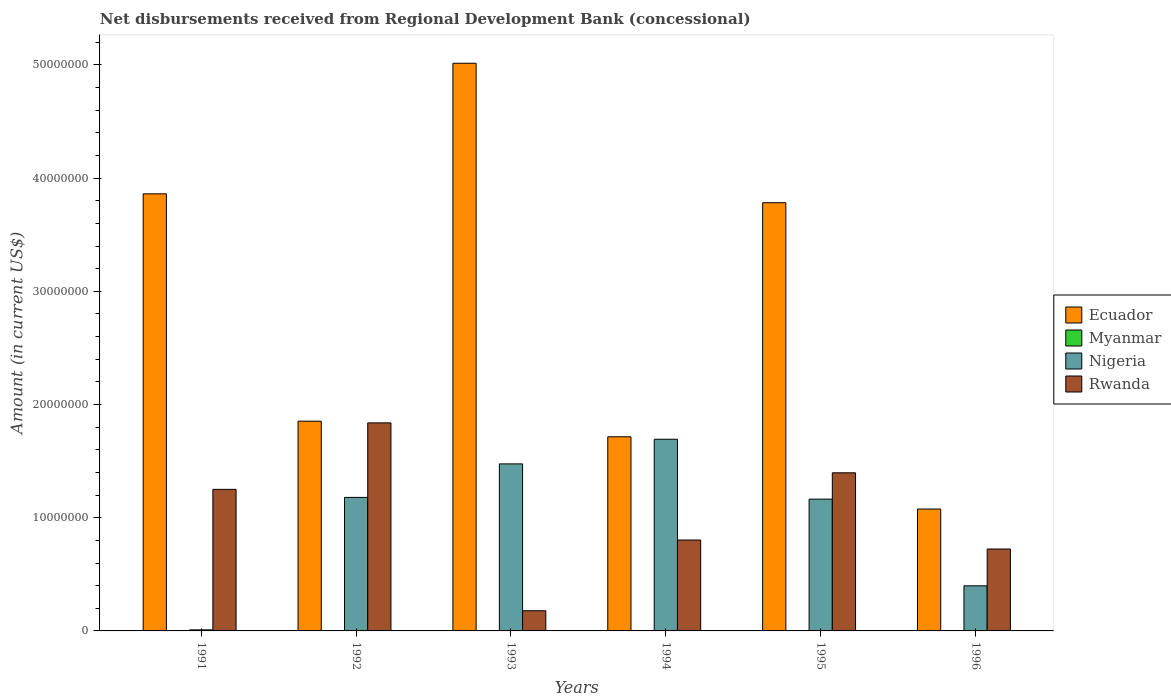How many different coloured bars are there?
Keep it short and to the point. 3. How many groups of bars are there?
Provide a short and direct response. 6. Are the number of bars per tick equal to the number of legend labels?
Your answer should be compact. No. How many bars are there on the 4th tick from the left?
Your answer should be compact. 3. How many bars are there on the 6th tick from the right?
Ensure brevity in your answer.  3. In how many cases, is the number of bars for a given year not equal to the number of legend labels?
Provide a short and direct response. 6. What is the amount of disbursements received from Regional Development Bank in Rwanda in 1993?
Ensure brevity in your answer.  1.78e+06. Across all years, what is the maximum amount of disbursements received from Regional Development Bank in Rwanda?
Your response must be concise. 1.84e+07. What is the total amount of disbursements received from Regional Development Bank in Rwanda in the graph?
Make the answer very short. 6.19e+07. What is the difference between the amount of disbursements received from Regional Development Bank in Nigeria in 1994 and that in 1996?
Offer a very short reply. 1.30e+07. What is the difference between the amount of disbursements received from Regional Development Bank in Myanmar in 1993 and the amount of disbursements received from Regional Development Bank in Rwanda in 1994?
Offer a very short reply. -8.03e+06. What is the average amount of disbursements received from Regional Development Bank in Nigeria per year?
Provide a succinct answer. 9.87e+06. In the year 1994, what is the difference between the amount of disbursements received from Regional Development Bank in Rwanda and amount of disbursements received from Regional Development Bank in Ecuador?
Make the answer very short. -9.12e+06. In how many years, is the amount of disbursements received from Regional Development Bank in Nigeria greater than 14000000 US$?
Your response must be concise. 2. What is the ratio of the amount of disbursements received from Regional Development Bank in Ecuador in 1992 to that in 1996?
Your response must be concise. 1.72. Is the amount of disbursements received from Regional Development Bank in Ecuador in 1994 less than that in 1995?
Ensure brevity in your answer.  Yes. What is the difference between the highest and the second highest amount of disbursements received from Regional Development Bank in Rwanda?
Give a very brief answer. 4.41e+06. What is the difference between the highest and the lowest amount of disbursements received from Regional Development Bank in Nigeria?
Give a very brief answer. 1.68e+07. How many bars are there?
Your answer should be very brief. 18. How many years are there in the graph?
Provide a short and direct response. 6. Are the values on the major ticks of Y-axis written in scientific E-notation?
Offer a terse response. No. Does the graph contain grids?
Offer a terse response. No. Where does the legend appear in the graph?
Your response must be concise. Center right. How many legend labels are there?
Provide a short and direct response. 4. How are the legend labels stacked?
Offer a very short reply. Vertical. What is the title of the graph?
Your answer should be very brief. Net disbursements received from Regional Development Bank (concessional). What is the label or title of the X-axis?
Keep it short and to the point. Years. What is the Amount (in current US$) in Ecuador in 1991?
Ensure brevity in your answer.  3.86e+07. What is the Amount (in current US$) of Nigeria in 1991?
Offer a terse response. 9.30e+04. What is the Amount (in current US$) in Rwanda in 1991?
Give a very brief answer. 1.25e+07. What is the Amount (in current US$) in Ecuador in 1992?
Provide a succinct answer. 1.85e+07. What is the Amount (in current US$) of Nigeria in 1992?
Offer a very short reply. 1.18e+07. What is the Amount (in current US$) in Rwanda in 1992?
Provide a succinct answer. 1.84e+07. What is the Amount (in current US$) of Ecuador in 1993?
Keep it short and to the point. 5.02e+07. What is the Amount (in current US$) of Myanmar in 1993?
Your answer should be very brief. 0. What is the Amount (in current US$) of Nigeria in 1993?
Your answer should be compact. 1.48e+07. What is the Amount (in current US$) of Rwanda in 1993?
Your response must be concise. 1.78e+06. What is the Amount (in current US$) in Ecuador in 1994?
Your answer should be very brief. 1.72e+07. What is the Amount (in current US$) in Nigeria in 1994?
Offer a terse response. 1.69e+07. What is the Amount (in current US$) of Rwanda in 1994?
Provide a short and direct response. 8.03e+06. What is the Amount (in current US$) of Ecuador in 1995?
Your answer should be very brief. 3.78e+07. What is the Amount (in current US$) of Nigeria in 1995?
Provide a short and direct response. 1.16e+07. What is the Amount (in current US$) of Rwanda in 1995?
Provide a short and direct response. 1.40e+07. What is the Amount (in current US$) in Ecuador in 1996?
Offer a very short reply. 1.08e+07. What is the Amount (in current US$) of Myanmar in 1996?
Provide a short and direct response. 0. What is the Amount (in current US$) in Nigeria in 1996?
Give a very brief answer. 3.98e+06. What is the Amount (in current US$) in Rwanda in 1996?
Your answer should be compact. 7.24e+06. Across all years, what is the maximum Amount (in current US$) of Ecuador?
Your answer should be very brief. 5.02e+07. Across all years, what is the maximum Amount (in current US$) of Nigeria?
Offer a terse response. 1.69e+07. Across all years, what is the maximum Amount (in current US$) of Rwanda?
Your answer should be compact. 1.84e+07. Across all years, what is the minimum Amount (in current US$) of Ecuador?
Provide a succinct answer. 1.08e+07. Across all years, what is the minimum Amount (in current US$) in Nigeria?
Offer a very short reply. 9.30e+04. Across all years, what is the minimum Amount (in current US$) in Rwanda?
Your answer should be very brief. 1.78e+06. What is the total Amount (in current US$) of Ecuador in the graph?
Your answer should be very brief. 1.73e+08. What is the total Amount (in current US$) in Nigeria in the graph?
Provide a short and direct response. 5.92e+07. What is the total Amount (in current US$) of Rwanda in the graph?
Offer a terse response. 6.19e+07. What is the difference between the Amount (in current US$) in Ecuador in 1991 and that in 1992?
Offer a very short reply. 2.01e+07. What is the difference between the Amount (in current US$) in Nigeria in 1991 and that in 1992?
Ensure brevity in your answer.  -1.17e+07. What is the difference between the Amount (in current US$) of Rwanda in 1991 and that in 1992?
Keep it short and to the point. -5.87e+06. What is the difference between the Amount (in current US$) of Ecuador in 1991 and that in 1993?
Provide a succinct answer. -1.15e+07. What is the difference between the Amount (in current US$) of Nigeria in 1991 and that in 1993?
Your response must be concise. -1.47e+07. What is the difference between the Amount (in current US$) in Rwanda in 1991 and that in 1993?
Make the answer very short. 1.07e+07. What is the difference between the Amount (in current US$) in Ecuador in 1991 and that in 1994?
Your answer should be compact. 2.15e+07. What is the difference between the Amount (in current US$) of Nigeria in 1991 and that in 1994?
Your response must be concise. -1.68e+07. What is the difference between the Amount (in current US$) of Rwanda in 1991 and that in 1994?
Your response must be concise. 4.48e+06. What is the difference between the Amount (in current US$) of Ecuador in 1991 and that in 1995?
Keep it short and to the point. 7.85e+05. What is the difference between the Amount (in current US$) of Nigeria in 1991 and that in 1995?
Keep it short and to the point. -1.16e+07. What is the difference between the Amount (in current US$) of Rwanda in 1991 and that in 1995?
Offer a very short reply. -1.46e+06. What is the difference between the Amount (in current US$) of Ecuador in 1991 and that in 1996?
Make the answer very short. 2.78e+07. What is the difference between the Amount (in current US$) in Nigeria in 1991 and that in 1996?
Make the answer very short. -3.89e+06. What is the difference between the Amount (in current US$) of Rwanda in 1991 and that in 1996?
Your response must be concise. 5.27e+06. What is the difference between the Amount (in current US$) of Ecuador in 1992 and that in 1993?
Provide a succinct answer. -3.16e+07. What is the difference between the Amount (in current US$) in Nigeria in 1992 and that in 1993?
Your response must be concise. -2.96e+06. What is the difference between the Amount (in current US$) of Rwanda in 1992 and that in 1993?
Keep it short and to the point. 1.66e+07. What is the difference between the Amount (in current US$) of Ecuador in 1992 and that in 1994?
Offer a terse response. 1.38e+06. What is the difference between the Amount (in current US$) of Nigeria in 1992 and that in 1994?
Provide a succinct answer. -5.14e+06. What is the difference between the Amount (in current US$) of Rwanda in 1992 and that in 1994?
Your response must be concise. 1.04e+07. What is the difference between the Amount (in current US$) of Ecuador in 1992 and that in 1995?
Offer a terse response. -1.93e+07. What is the difference between the Amount (in current US$) of Nigeria in 1992 and that in 1995?
Provide a short and direct response. 1.54e+05. What is the difference between the Amount (in current US$) in Rwanda in 1992 and that in 1995?
Your response must be concise. 4.41e+06. What is the difference between the Amount (in current US$) in Ecuador in 1992 and that in 1996?
Offer a very short reply. 7.76e+06. What is the difference between the Amount (in current US$) in Nigeria in 1992 and that in 1996?
Give a very brief answer. 7.81e+06. What is the difference between the Amount (in current US$) in Rwanda in 1992 and that in 1996?
Provide a succinct answer. 1.11e+07. What is the difference between the Amount (in current US$) in Ecuador in 1993 and that in 1994?
Provide a succinct answer. 3.30e+07. What is the difference between the Amount (in current US$) of Nigeria in 1993 and that in 1994?
Offer a very short reply. -2.18e+06. What is the difference between the Amount (in current US$) of Rwanda in 1993 and that in 1994?
Provide a succinct answer. -6.25e+06. What is the difference between the Amount (in current US$) of Ecuador in 1993 and that in 1995?
Offer a terse response. 1.23e+07. What is the difference between the Amount (in current US$) of Nigeria in 1993 and that in 1995?
Keep it short and to the point. 3.11e+06. What is the difference between the Amount (in current US$) in Rwanda in 1993 and that in 1995?
Your answer should be very brief. -1.22e+07. What is the difference between the Amount (in current US$) in Ecuador in 1993 and that in 1996?
Make the answer very short. 3.94e+07. What is the difference between the Amount (in current US$) in Nigeria in 1993 and that in 1996?
Provide a short and direct response. 1.08e+07. What is the difference between the Amount (in current US$) in Rwanda in 1993 and that in 1996?
Your answer should be compact. -5.45e+06. What is the difference between the Amount (in current US$) of Ecuador in 1994 and that in 1995?
Offer a terse response. -2.07e+07. What is the difference between the Amount (in current US$) of Nigeria in 1994 and that in 1995?
Your answer should be very brief. 5.29e+06. What is the difference between the Amount (in current US$) in Rwanda in 1994 and that in 1995?
Your response must be concise. -5.94e+06. What is the difference between the Amount (in current US$) of Ecuador in 1994 and that in 1996?
Your answer should be very brief. 6.38e+06. What is the difference between the Amount (in current US$) in Nigeria in 1994 and that in 1996?
Ensure brevity in your answer.  1.30e+07. What is the difference between the Amount (in current US$) of Rwanda in 1994 and that in 1996?
Your answer should be compact. 7.94e+05. What is the difference between the Amount (in current US$) of Ecuador in 1995 and that in 1996?
Give a very brief answer. 2.71e+07. What is the difference between the Amount (in current US$) in Nigeria in 1995 and that in 1996?
Your answer should be compact. 7.66e+06. What is the difference between the Amount (in current US$) of Rwanda in 1995 and that in 1996?
Keep it short and to the point. 6.73e+06. What is the difference between the Amount (in current US$) of Ecuador in 1991 and the Amount (in current US$) of Nigeria in 1992?
Provide a succinct answer. 2.68e+07. What is the difference between the Amount (in current US$) in Ecuador in 1991 and the Amount (in current US$) in Rwanda in 1992?
Your response must be concise. 2.02e+07. What is the difference between the Amount (in current US$) of Nigeria in 1991 and the Amount (in current US$) of Rwanda in 1992?
Your response must be concise. -1.83e+07. What is the difference between the Amount (in current US$) in Ecuador in 1991 and the Amount (in current US$) in Nigeria in 1993?
Your answer should be compact. 2.39e+07. What is the difference between the Amount (in current US$) in Ecuador in 1991 and the Amount (in current US$) in Rwanda in 1993?
Make the answer very short. 3.68e+07. What is the difference between the Amount (in current US$) in Nigeria in 1991 and the Amount (in current US$) in Rwanda in 1993?
Offer a very short reply. -1.69e+06. What is the difference between the Amount (in current US$) in Ecuador in 1991 and the Amount (in current US$) in Nigeria in 1994?
Provide a short and direct response. 2.17e+07. What is the difference between the Amount (in current US$) in Ecuador in 1991 and the Amount (in current US$) in Rwanda in 1994?
Your answer should be compact. 3.06e+07. What is the difference between the Amount (in current US$) in Nigeria in 1991 and the Amount (in current US$) in Rwanda in 1994?
Your answer should be compact. -7.94e+06. What is the difference between the Amount (in current US$) of Ecuador in 1991 and the Amount (in current US$) of Nigeria in 1995?
Offer a very short reply. 2.70e+07. What is the difference between the Amount (in current US$) of Ecuador in 1991 and the Amount (in current US$) of Rwanda in 1995?
Offer a very short reply. 2.46e+07. What is the difference between the Amount (in current US$) of Nigeria in 1991 and the Amount (in current US$) of Rwanda in 1995?
Your answer should be very brief. -1.39e+07. What is the difference between the Amount (in current US$) of Ecuador in 1991 and the Amount (in current US$) of Nigeria in 1996?
Your answer should be compact. 3.46e+07. What is the difference between the Amount (in current US$) in Ecuador in 1991 and the Amount (in current US$) in Rwanda in 1996?
Make the answer very short. 3.14e+07. What is the difference between the Amount (in current US$) in Nigeria in 1991 and the Amount (in current US$) in Rwanda in 1996?
Make the answer very short. -7.14e+06. What is the difference between the Amount (in current US$) of Ecuador in 1992 and the Amount (in current US$) of Nigeria in 1993?
Your answer should be very brief. 3.77e+06. What is the difference between the Amount (in current US$) in Ecuador in 1992 and the Amount (in current US$) in Rwanda in 1993?
Keep it short and to the point. 1.67e+07. What is the difference between the Amount (in current US$) of Nigeria in 1992 and the Amount (in current US$) of Rwanda in 1993?
Provide a succinct answer. 1.00e+07. What is the difference between the Amount (in current US$) in Ecuador in 1992 and the Amount (in current US$) in Nigeria in 1994?
Keep it short and to the point. 1.60e+06. What is the difference between the Amount (in current US$) in Ecuador in 1992 and the Amount (in current US$) in Rwanda in 1994?
Your answer should be very brief. 1.05e+07. What is the difference between the Amount (in current US$) in Nigeria in 1992 and the Amount (in current US$) in Rwanda in 1994?
Keep it short and to the point. 3.77e+06. What is the difference between the Amount (in current US$) of Ecuador in 1992 and the Amount (in current US$) of Nigeria in 1995?
Your answer should be compact. 6.89e+06. What is the difference between the Amount (in current US$) of Ecuador in 1992 and the Amount (in current US$) of Rwanda in 1995?
Provide a succinct answer. 4.56e+06. What is the difference between the Amount (in current US$) of Nigeria in 1992 and the Amount (in current US$) of Rwanda in 1995?
Offer a terse response. -2.17e+06. What is the difference between the Amount (in current US$) in Ecuador in 1992 and the Amount (in current US$) in Nigeria in 1996?
Your answer should be very brief. 1.45e+07. What is the difference between the Amount (in current US$) of Ecuador in 1992 and the Amount (in current US$) of Rwanda in 1996?
Provide a succinct answer. 1.13e+07. What is the difference between the Amount (in current US$) of Nigeria in 1992 and the Amount (in current US$) of Rwanda in 1996?
Provide a short and direct response. 4.56e+06. What is the difference between the Amount (in current US$) in Ecuador in 1993 and the Amount (in current US$) in Nigeria in 1994?
Your answer should be compact. 3.32e+07. What is the difference between the Amount (in current US$) of Ecuador in 1993 and the Amount (in current US$) of Rwanda in 1994?
Your answer should be compact. 4.21e+07. What is the difference between the Amount (in current US$) of Nigeria in 1993 and the Amount (in current US$) of Rwanda in 1994?
Offer a terse response. 6.73e+06. What is the difference between the Amount (in current US$) of Ecuador in 1993 and the Amount (in current US$) of Nigeria in 1995?
Ensure brevity in your answer.  3.85e+07. What is the difference between the Amount (in current US$) in Ecuador in 1993 and the Amount (in current US$) in Rwanda in 1995?
Your answer should be very brief. 3.62e+07. What is the difference between the Amount (in current US$) in Nigeria in 1993 and the Amount (in current US$) in Rwanda in 1995?
Offer a very short reply. 7.88e+05. What is the difference between the Amount (in current US$) of Ecuador in 1993 and the Amount (in current US$) of Nigeria in 1996?
Ensure brevity in your answer.  4.62e+07. What is the difference between the Amount (in current US$) of Ecuador in 1993 and the Amount (in current US$) of Rwanda in 1996?
Offer a very short reply. 4.29e+07. What is the difference between the Amount (in current US$) of Nigeria in 1993 and the Amount (in current US$) of Rwanda in 1996?
Offer a very short reply. 7.52e+06. What is the difference between the Amount (in current US$) of Ecuador in 1994 and the Amount (in current US$) of Nigeria in 1995?
Your answer should be compact. 5.51e+06. What is the difference between the Amount (in current US$) of Ecuador in 1994 and the Amount (in current US$) of Rwanda in 1995?
Your response must be concise. 3.18e+06. What is the difference between the Amount (in current US$) of Nigeria in 1994 and the Amount (in current US$) of Rwanda in 1995?
Provide a short and direct response. 2.97e+06. What is the difference between the Amount (in current US$) of Ecuador in 1994 and the Amount (in current US$) of Nigeria in 1996?
Your answer should be compact. 1.32e+07. What is the difference between the Amount (in current US$) in Ecuador in 1994 and the Amount (in current US$) in Rwanda in 1996?
Make the answer very short. 9.91e+06. What is the difference between the Amount (in current US$) in Nigeria in 1994 and the Amount (in current US$) in Rwanda in 1996?
Keep it short and to the point. 9.70e+06. What is the difference between the Amount (in current US$) in Ecuador in 1995 and the Amount (in current US$) in Nigeria in 1996?
Make the answer very short. 3.38e+07. What is the difference between the Amount (in current US$) of Ecuador in 1995 and the Amount (in current US$) of Rwanda in 1996?
Offer a terse response. 3.06e+07. What is the difference between the Amount (in current US$) of Nigeria in 1995 and the Amount (in current US$) of Rwanda in 1996?
Give a very brief answer. 4.41e+06. What is the average Amount (in current US$) of Ecuador per year?
Provide a short and direct response. 2.88e+07. What is the average Amount (in current US$) in Nigeria per year?
Give a very brief answer. 9.87e+06. What is the average Amount (in current US$) in Rwanda per year?
Provide a short and direct response. 1.03e+07. In the year 1991, what is the difference between the Amount (in current US$) of Ecuador and Amount (in current US$) of Nigeria?
Give a very brief answer. 3.85e+07. In the year 1991, what is the difference between the Amount (in current US$) of Ecuador and Amount (in current US$) of Rwanda?
Your response must be concise. 2.61e+07. In the year 1991, what is the difference between the Amount (in current US$) of Nigeria and Amount (in current US$) of Rwanda?
Offer a terse response. -1.24e+07. In the year 1992, what is the difference between the Amount (in current US$) of Ecuador and Amount (in current US$) of Nigeria?
Keep it short and to the point. 6.73e+06. In the year 1992, what is the difference between the Amount (in current US$) of Ecuador and Amount (in current US$) of Rwanda?
Your answer should be very brief. 1.49e+05. In the year 1992, what is the difference between the Amount (in current US$) of Nigeria and Amount (in current US$) of Rwanda?
Your response must be concise. -6.58e+06. In the year 1993, what is the difference between the Amount (in current US$) in Ecuador and Amount (in current US$) in Nigeria?
Your answer should be very brief. 3.54e+07. In the year 1993, what is the difference between the Amount (in current US$) in Ecuador and Amount (in current US$) in Rwanda?
Give a very brief answer. 4.84e+07. In the year 1993, what is the difference between the Amount (in current US$) of Nigeria and Amount (in current US$) of Rwanda?
Provide a succinct answer. 1.30e+07. In the year 1994, what is the difference between the Amount (in current US$) of Ecuador and Amount (in current US$) of Nigeria?
Ensure brevity in your answer.  2.16e+05. In the year 1994, what is the difference between the Amount (in current US$) in Ecuador and Amount (in current US$) in Rwanda?
Your response must be concise. 9.12e+06. In the year 1994, what is the difference between the Amount (in current US$) in Nigeria and Amount (in current US$) in Rwanda?
Ensure brevity in your answer.  8.90e+06. In the year 1995, what is the difference between the Amount (in current US$) of Ecuador and Amount (in current US$) of Nigeria?
Offer a very short reply. 2.62e+07. In the year 1995, what is the difference between the Amount (in current US$) of Ecuador and Amount (in current US$) of Rwanda?
Your answer should be compact. 2.39e+07. In the year 1995, what is the difference between the Amount (in current US$) of Nigeria and Amount (in current US$) of Rwanda?
Offer a terse response. -2.33e+06. In the year 1996, what is the difference between the Amount (in current US$) in Ecuador and Amount (in current US$) in Nigeria?
Your answer should be compact. 6.78e+06. In the year 1996, what is the difference between the Amount (in current US$) of Ecuador and Amount (in current US$) of Rwanda?
Provide a succinct answer. 3.53e+06. In the year 1996, what is the difference between the Amount (in current US$) of Nigeria and Amount (in current US$) of Rwanda?
Keep it short and to the point. -3.25e+06. What is the ratio of the Amount (in current US$) of Ecuador in 1991 to that in 1992?
Offer a very short reply. 2.08. What is the ratio of the Amount (in current US$) of Nigeria in 1991 to that in 1992?
Your answer should be compact. 0.01. What is the ratio of the Amount (in current US$) in Rwanda in 1991 to that in 1992?
Provide a succinct answer. 0.68. What is the ratio of the Amount (in current US$) of Ecuador in 1991 to that in 1993?
Your answer should be very brief. 0.77. What is the ratio of the Amount (in current US$) in Nigeria in 1991 to that in 1993?
Provide a succinct answer. 0.01. What is the ratio of the Amount (in current US$) of Rwanda in 1991 to that in 1993?
Offer a very short reply. 7.01. What is the ratio of the Amount (in current US$) in Ecuador in 1991 to that in 1994?
Offer a very short reply. 2.25. What is the ratio of the Amount (in current US$) of Nigeria in 1991 to that in 1994?
Your answer should be compact. 0.01. What is the ratio of the Amount (in current US$) in Rwanda in 1991 to that in 1994?
Your response must be concise. 1.56. What is the ratio of the Amount (in current US$) in Ecuador in 1991 to that in 1995?
Keep it short and to the point. 1.02. What is the ratio of the Amount (in current US$) of Nigeria in 1991 to that in 1995?
Provide a succinct answer. 0.01. What is the ratio of the Amount (in current US$) in Rwanda in 1991 to that in 1995?
Provide a succinct answer. 0.9. What is the ratio of the Amount (in current US$) of Ecuador in 1991 to that in 1996?
Keep it short and to the point. 3.59. What is the ratio of the Amount (in current US$) of Nigeria in 1991 to that in 1996?
Give a very brief answer. 0.02. What is the ratio of the Amount (in current US$) of Rwanda in 1991 to that in 1996?
Provide a short and direct response. 1.73. What is the ratio of the Amount (in current US$) of Ecuador in 1992 to that in 1993?
Keep it short and to the point. 0.37. What is the ratio of the Amount (in current US$) of Nigeria in 1992 to that in 1993?
Your response must be concise. 0.8. What is the ratio of the Amount (in current US$) in Rwanda in 1992 to that in 1993?
Offer a terse response. 10.31. What is the ratio of the Amount (in current US$) of Ecuador in 1992 to that in 1994?
Provide a short and direct response. 1.08. What is the ratio of the Amount (in current US$) in Nigeria in 1992 to that in 1994?
Provide a succinct answer. 0.7. What is the ratio of the Amount (in current US$) of Rwanda in 1992 to that in 1994?
Your response must be concise. 2.29. What is the ratio of the Amount (in current US$) in Ecuador in 1992 to that in 1995?
Your response must be concise. 0.49. What is the ratio of the Amount (in current US$) in Nigeria in 1992 to that in 1995?
Keep it short and to the point. 1.01. What is the ratio of the Amount (in current US$) of Rwanda in 1992 to that in 1995?
Make the answer very short. 1.32. What is the ratio of the Amount (in current US$) of Ecuador in 1992 to that in 1996?
Your answer should be very brief. 1.72. What is the ratio of the Amount (in current US$) in Nigeria in 1992 to that in 1996?
Ensure brevity in your answer.  2.96. What is the ratio of the Amount (in current US$) in Rwanda in 1992 to that in 1996?
Your response must be concise. 2.54. What is the ratio of the Amount (in current US$) of Ecuador in 1993 to that in 1994?
Ensure brevity in your answer.  2.92. What is the ratio of the Amount (in current US$) of Nigeria in 1993 to that in 1994?
Provide a short and direct response. 0.87. What is the ratio of the Amount (in current US$) of Rwanda in 1993 to that in 1994?
Make the answer very short. 0.22. What is the ratio of the Amount (in current US$) of Ecuador in 1993 to that in 1995?
Your response must be concise. 1.33. What is the ratio of the Amount (in current US$) in Nigeria in 1993 to that in 1995?
Keep it short and to the point. 1.27. What is the ratio of the Amount (in current US$) in Rwanda in 1993 to that in 1995?
Keep it short and to the point. 0.13. What is the ratio of the Amount (in current US$) in Ecuador in 1993 to that in 1996?
Your answer should be compact. 4.66. What is the ratio of the Amount (in current US$) in Nigeria in 1993 to that in 1996?
Keep it short and to the point. 3.7. What is the ratio of the Amount (in current US$) of Rwanda in 1993 to that in 1996?
Give a very brief answer. 0.25. What is the ratio of the Amount (in current US$) of Ecuador in 1994 to that in 1995?
Provide a succinct answer. 0.45. What is the ratio of the Amount (in current US$) of Nigeria in 1994 to that in 1995?
Your response must be concise. 1.45. What is the ratio of the Amount (in current US$) of Rwanda in 1994 to that in 1995?
Offer a terse response. 0.57. What is the ratio of the Amount (in current US$) in Ecuador in 1994 to that in 1996?
Your response must be concise. 1.59. What is the ratio of the Amount (in current US$) of Nigeria in 1994 to that in 1996?
Provide a short and direct response. 4.25. What is the ratio of the Amount (in current US$) in Rwanda in 1994 to that in 1996?
Provide a short and direct response. 1.11. What is the ratio of the Amount (in current US$) of Ecuador in 1995 to that in 1996?
Provide a succinct answer. 3.51. What is the ratio of the Amount (in current US$) of Nigeria in 1995 to that in 1996?
Your answer should be compact. 2.92. What is the ratio of the Amount (in current US$) of Rwanda in 1995 to that in 1996?
Provide a short and direct response. 1.93. What is the difference between the highest and the second highest Amount (in current US$) in Ecuador?
Your answer should be compact. 1.15e+07. What is the difference between the highest and the second highest Amount (in current US$) in Nigeria?
Offer a very short reply. 2.18e+06. What is the difference between the highest and the second highest Amount (in current US$) in Rwanda?
Offer a very short reply. 4.41e+06. What is the difference between the highest and the lowest Amount (in current US$) in Ecuador?
Your response must be concise. 3.94e+07. What is the difference between the highest and the lowest Amount (in current US$) of Nigeria?
Give a very brief answer. 1.68e+07. What is the difference between the highest and the lowest Amount (in current US$) of Rwanda?
Your response must be concise. 1.66e+07. 